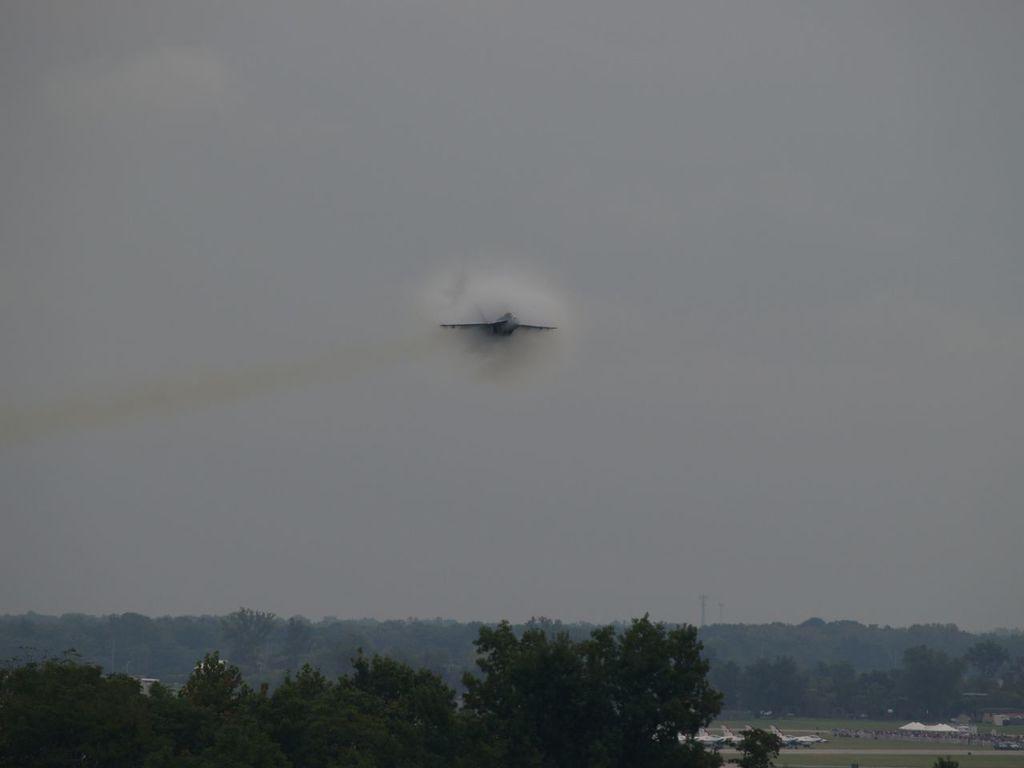In one or two sentences, can you explain what this image depicts? As we can see in the image there are trees, plants, grass and sky. 